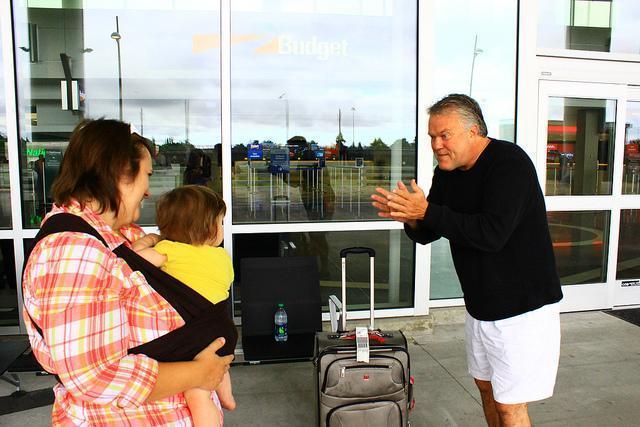How many suitcases are in the photo?
Give a very brief answer. 2. How many people are there?
Give a very brief answer. 3. 